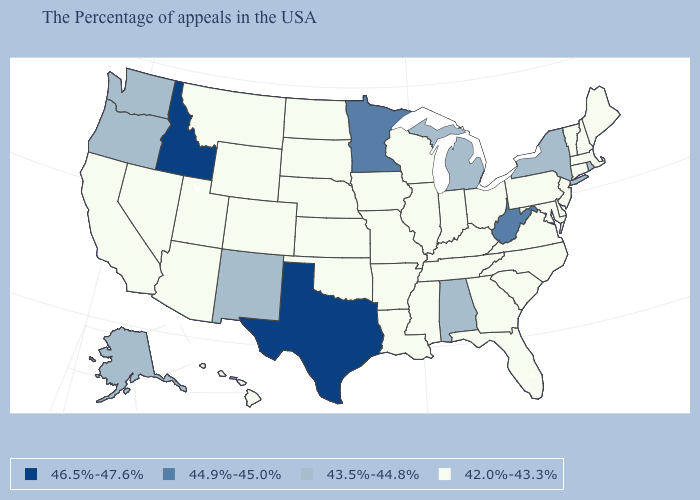Does Connecticut have the lowest value in the Northeast?
Keep it brief. Yes. What is the value of Wisconsin?
Keep it brief. 42.0%-43.3%. What is the value of Virginia?
Write a very short answer. 42.0%-43.3%. Name the states that have a value in the range 46.5%-47.6%?
Answer briefly. Texas, Idaho. What is the value of Maryland?
Be succinct. 42.0%-43.3%. Name the states that have a value in the range 44.9%-45.0%?
Write a very short answer. West Virginia, Minnesota. Name the states that have a value in the range 43.5%-44.8%?
Be succinct. Rhode Island, New York, Michigan, Alabama, New Mexico, Washington, Oregon, Alaska. Name the states that have a value in the range 44.9%-45.0%?
Be succinct. West Virginia, Minnesota. What is the value of Pennsylvania?
Concise answer only. 42.0%-43.3%. What is the highest value in the USA?
Concise answer only. 46.5%-47.6%. Does Idaho have the same value as Oklahoma?
Answer briefly. No. Is the legend a continuous bar?
Be succinct. No. What is the lowest value in states that border Nebraska?
Give a very brief answer. 42.0%-43.3%. How many symbols are there in the legend?
Concise answer only. 4. What is the lowest value in the MidWest?
Quick response, please. 42.0%-43.3%. 